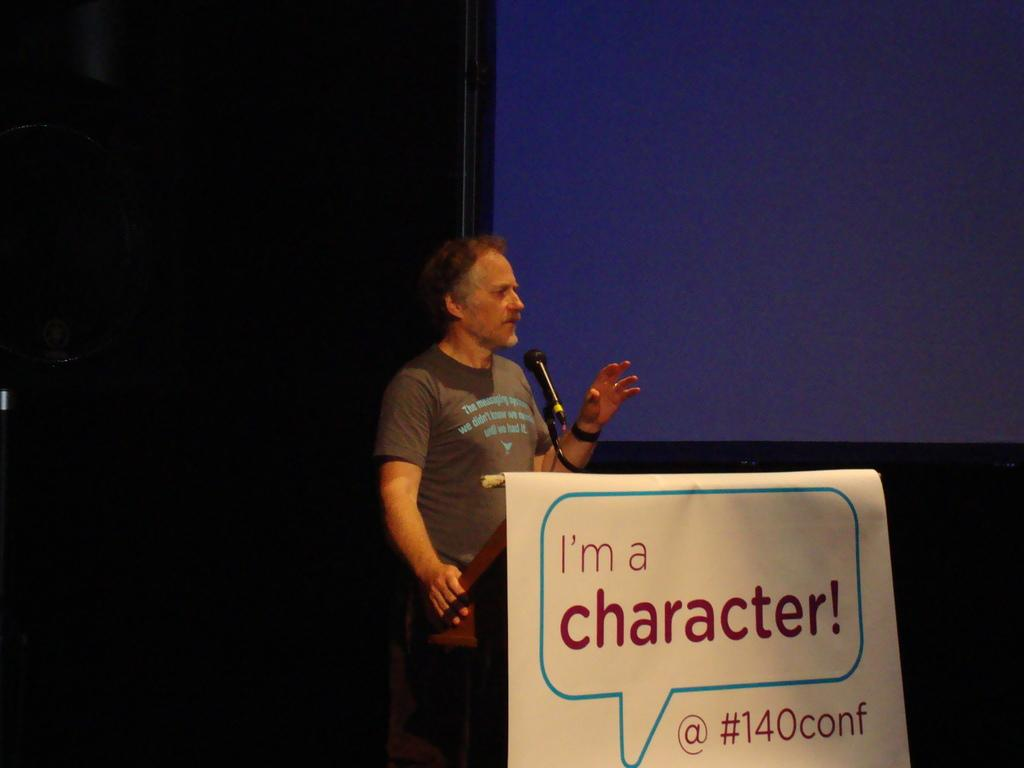What is the man in the image doing? The man is standing in the center of the image. What object is in front of the man? There is a podium in front of the man. What is on the podium? A microphone is present on the podium. What can be seen in the background of the image? There is a screen in the background of the image. What time is displayed on the clock in the image? There is no clock present in the image. 